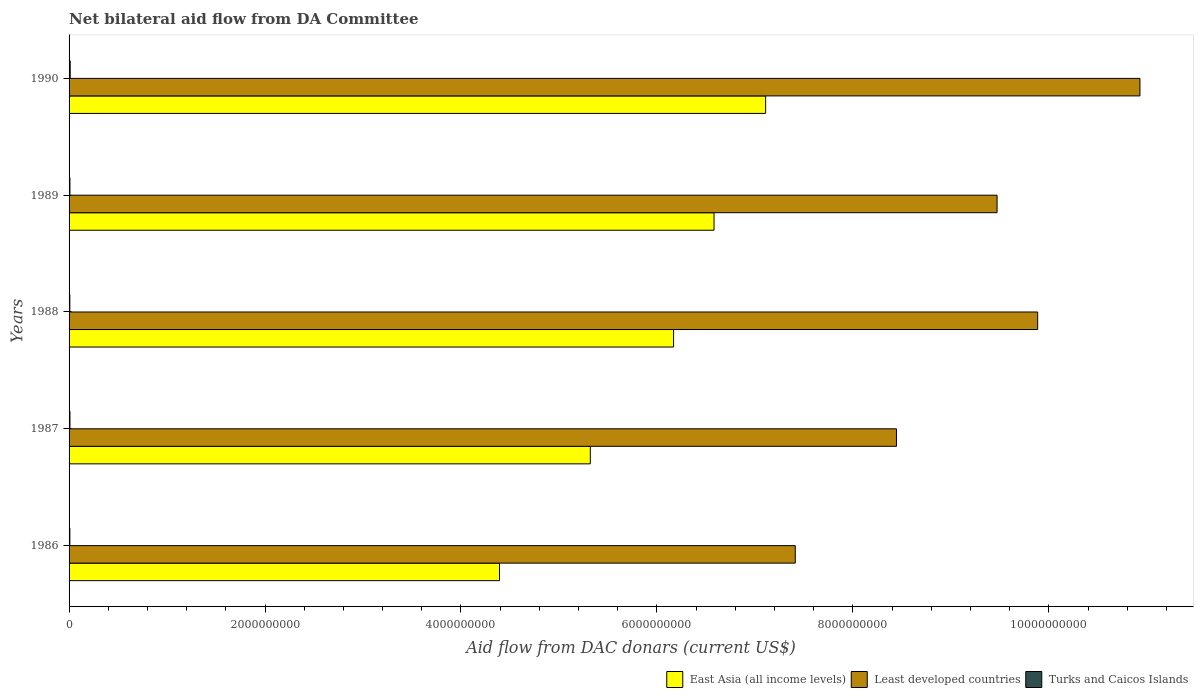How many different coloured bars are there?
Offer a terse response. 3. How many groups of bars are there?
Provide a succinct answer. 5. Are the number of bars per tick equal to the number of legend labels?
Your answer should be very brief. Yes. Are the number of bars on each tick of the Y-axis equal?
Make the answer very short. Yes. What is the aid flow in in Least developed countries in 1990?
Offer a terse response. 1.09e+1. Across all years, what is the maximum aid flow in in Least developed countries?
Offer a terse response. 1.09e+1. Across all years, what is the minimum aid flow in in Turks and Caicos Islands?
Your answer should be very brief. 7.69e+06. In which year was the aid flow in in Turks and Caicos Islands minimum?
Ensure brevity in your answer.  1988. What is the total aid flow in in Least developed countries in the graph?
Ensure brevity in your answer.  4.61e+1. What is the difference between the aid flow in in Turks and Caicos Islands in 1987 and that in 1989?
Your response must be concise. 4.00e+05. What is the difference between the aid flow in in Least developed countries in 1987 and the aid flow in in Turks and Caicos Islands in 1989?
Your response must be concise. 8.44e+09. What is the average aid flow in in East Asia (all income levels) per year?
Offer a terse response. 5.92e+09. In the year 1990, what is the difference between the aid flow in in East Asia (all income levels) and aid flow in in Turks and Caicos Islands?
Your answer should be compact. 7.10e+09. What is the ratio of the aid flow in in Turks and Caicos Islands in 1986 to that in 1989?
Keep it short and to the point. 0.92. Is the aid flow in in Least developed countries in 1987 less than that in 1990?
Your response must be concise. Yes. What is the difference between the highest and the second highest aid flow in in Turks and Caicos Islands?
Offer a terse response. 2.37e+06. What is the difference between the highest and the lowest aid flow in in Turks and Caicos Islands?
Offer a terse response. 3.76e+06. In how many years, is the aid flow in in Least developed countries greater than the average aid flow in in Least developed countries taken over all years?
Offer a terse response. 3. Is the sum of the aid flow in in Turks and Caicos Islands in 1988 and 1990 greater than the maximum aid flow in in East Asia (all income levels) across all years?
Give a very brief answer. No. What does the 2nd bar from the top in 1986 represents?
Give a very brief answer. Least developed countries. What does the 1st bar from the bottom in 1990 represents?
Provide a short and direct response. East Asia (all income levels). Is it the case that in every year, the sum of the aid flow in in Turks and Caicos Islands and aid flow in in East Asia (all income levels) is greater than the aid flow in in Least developed countries?
Keep it short and to the point. No. Are all the bars in the graph horizontal?
Offer a terse response. Yes. What is the difference between two consecutive major ticks on the X-axis?
Provide a short and direct response. 2.00e+09. Does the graph contain grids?
Provide a succinct answer. No. How many legend labels are there?
Give a very brief answer. 3. What is the title of the graph?
Make the answer very short. Net bilateral aid flow from DA Committee. What is the label or title of the X-axis?
Provide a short and direct response. Aid flow from DAC donars (current US$). What is the label or title of the Y-axis?
Your response must be concise. Years. What is the Aid flow from DAC donars (current US$) of East Asia (all income levels) in 1986?
Make the answer very short. 4.39e+09. What is the Aid flow from DAC donars (current US$) in Least developed countries in 1986?
Offer a terse response. 7.41e+09. What is the Aid flow from DAC donars (current US$) of East Asia (all income levels) in 1987?
Provide a succinct answer. 5.32e+09. What is the Aid flow from DAC donars (current US$) of Least developed countries in 1987?
Your response must be concise. 8.45e+09. What is the Aid flow from DAC donars (current US$) in Turks and Caicos Islands in 1987?
Your answer should be very brief. 9.08e+06. What is the Aid flow from DAC donars (current US$) of East Asia (all income levels) in 1988?
Keep it short and to the point. 6.17e+09. What is the Aid flow from DAC donars (current US$) in Least developed countries in 1988?
Your answer should be very brief. 9.89e+09. What is the Aid flow from DAC donars (current US$) of Turks and Caicos Islands in 1988?
Keep it short and to the point. 7.69e+06. What is the Aid flow from DAC donars (current US$) in East Asia (all income levels) in 1989?
Your answer should be compact. 6.58e+09. What is the Aid flow from DAC donars (current US$) of Least developed countries in 1989?
Your answer should be compact. 9.47e+09. What is the Aid flow from DAC donars (current US$) in Turks and Caicos Islands in 1989?
Offer a very short reply. 8.68e+06. What is the Aid flow from DAC donars (current US$) in East Asia (all income levels) in 1990?
Your answer should be very brief. 7.11e+09. What is the Aid flow from DAC donars (current US$) in Least developed countries in 1990?
Keep it short and to the point. 1.09e+1. What is the Aid flow from DAC donars (current US$) of Turks and Caicos Islands in 1990?
Keep it short and to the point. 1.14e+07. Across all years, what is the maximum Aid flow from DAC donars (current US$) in East Asia (all income levels)?
Offer a terse response. 7.11e+09. Across all years, what is the maximum Aid flow from DAC donars (current US$) in Least developed countries?
Provide a short and direct response. 1.09e+1. Across all years, what is the maximum Aid flow from DAC donars (current US$) in Turks and Caicos Islands?
Offer a terse response. 1.14e+07. Across all years, what is the minimum Aid flow from DAC donars (current US$) of East Asia (all income levels)?
Ensure brevity in your answer.  4.39e+09. Across all years, what is the minimum Aid flow from DAC donars (current US$) of Least developed countries?
Your answer should be compact. 7.41e+09. Across all years, what is the minimum Aid flow from DAC donars (current US$) of Turks and Caicos Islands?
Your response must be concise. 7.69e+06. What is the total Aid flow from DAC donars (current US$) of East Asia (all income levels) in the graph?
Your answer should be very brief. 2.96e+1. What is the total Aid flow from DAC donars (current US$) in Least developed countries in the graph?
Your answer should be very brief. 4.61e+1. What is the total Aid flow from DAC donars (current US$) of Turks and Caicos Islands in the graph?
Make the answer very short. 4.49e+07. What is the difference between the Aid flow from DAC donars (current US$) in East Asia (all income levels) in 1986 and that in 1987?
Provide a short and direct response. -9.27e+08. What is the difference between the Aid flow from DAC donars (current US$) of Least developed countries in 1986 and that in 1987?
Provide a short and direct response. -1.03e+09. What is the difference between the Aid flow from DAC donars (current US$) in Turks and Caicos Islands in 1986 and that in 1987?
Provide a short and direct response. -1.08e+06. What is the difference between the Aid flow from DAC donars (current US$) of East Asia (all income levels) in 1986 and that in 1988?
Give a very brief answer. -1.78e+09. What is the difference between the Aid flow from DAC donars (current US$) in Least developed countries in 1986 and that in 1988?
Provide a short and direct response. -2.47e+09. What is the difference between the Aid flow from DAC donars (current US$) in East Asia (all income levels) in 1986 and that in 1989?
Your answer should be compact. -2.19e+09. What is the difference between the Aid flow from DAC donars (current US$) of Least developed countries in 1986 and that in 1989?
Keep it short and to the point. -2.06e+09. What is the difference between the Aid flow from DAC donars (current US$) in Turks and Caicos Islands in 1986 and that in 1989?
Offer a very short reply. -6.80e+05. What is the difference between the Aid flow from DAC donars (current US$) of East Asia (all income levels) in 1986 and that in 1990?
Offer a very short reply. -2.72e+09. What is the difference between the Aid flow from DAC donars (current US$) in Least developed countries in 1986 and that in 1990?
Your response must be concise. -3.52e+09. What is the difference between the Aid flow from DAC donars (current US$) of Turks and Caicos Islands in 1986 and that in 1990?
Provide a succinct answer. -3.45e+06. What is the difference between the Aid flow from DAC donars (current US$) of East Asia (all income levels) in 1987 and that in 1988?
Keep it short and to the point. -8.50e+08. What is the difference between the Aid flow from DAC donars (current US$) of Least developed countries in 1987 and that in 1988?
Make the answer very short. -1.44e+09. What is the difference between the Aid flow from DAC donars (current US$) of Turks and Caicos Islands in 1987 and that in 1988?
Offer a terse response. 1.39e+06. What is the difference between the Aid flow from DAC donars (current US$) in East Asia (all income levels) in 1987 and that in 1989?
Provide a succinct answer. -1.26e+09. What is the difference between the Aid flow from DAC donars (current US$) of Least developed countries in 1987 and that in 1989?
Give a very brief answer. -1.03e+09. What is the difference between the Aid flow from DAC donars (current US$) in East Asia (all income levels) in 1987 and that in 1990?
Provide a succinct answer. -1.79e+09. What is the difference between the Aid flow from DAC donars (current US$) in Least developed countries in 1987 and that in 1990?
Your answer should be compact. -2.49e+09. What is the difference between the Aid flow from DAC donars (current US$) of Turks and Caicos Islands in 1987 and that in 1990?
Offer a terse response. -2.37e+06. What is the difference between the Aid flow from DAC donars (current US$) in East Asia (all income levels) in 1988 and that in 1989?
Offer a very short reply. -4.13e+08. What is the difference between the Aid flow from DAC donars (current US$) in Least developed countries in 1988 and that in 1989?
Provide a succinct answer. 4.14e+08. What is the difference between the Aid flow from DAC donars (current US$) of Turks and Caicos Islands in 1988 and that in 1989?
Your answer should be very brief. -9.90e+05. What is the difference between the Aid flow from DAC donars (current US$) of East Asia (all income levels) in 1988 and that in 1990?
Keep it short and to the point. -9.40e+08. What is the difference between the Aid flow from DAC donars (current US$) of Least developed countries in 1988 and that in 1990?
Your answer should be compact. -1.04e+09. What is the difference between the Aid flow from DAC donars (current US$) in Turks and Caicos Islands in 1988 and that in 1990?
Provide a succinct answer. -3.76e+06. What is the difference between the Aid flow from DAC donars (current US$) in East Asia (all income levels) in 1989 and that in 1990?
Ensure brevity in your answer.  -5.27e+08. What is the difference between the Aid flow from DAC donars (current US$) in Least developed countries in 1989 and that in 1990?
Make the answer very short. -1.46e+09. What is the difference between the Aid flow from DAC donars (current US$) of Turks and Caicos Islands in 1989 and that in 1990?
Provide a succinct answer. -2.77e+06. What is the difference between the Aid flow from DAC donars (current US$) of East Asia (all income levels) in 1986 and the Aid flow from DAC donars (current US$) of Least developed countries in 1987?
Your response must be concise. -4.05e+09. What is the difference between the Aid flow from DAC donars (current US$) in East Asia (all income levels) in 1986 and the Aid flow from DAC donars (current US$) in Turks and Caicos Islands in 1987?
Give a very brief answer. 4.38e+09. What is the difference between the Aid flow from DAC donars (current US$) in Least developed countries in 1986 and the Aid flow from DAC donars (current US$) in Turks and Caicos Islands in 1987?
Provide a succinct answer. 7.40e+09. What is the difference between the Aid flow from DAC donars (current US$) of East Asia (all income levels) in 1986 and the Aid flow from DAC donars (current US$) of Least developed countries in 1988?
Provide a succinct answer. -5.49e+09. What is the difference between the Aid flow from DAC donars (current US$) in East Asia (all income levels) in 1986 and the Aid flow from DAC donars (current US$) in Turks and Caicos Islands in 1988?
Keep it short and to the point. 4.39e+09. What is the difference between the Aid flow from DAC donars (current US$) in Least developed countries in 1986 and the Aid flow from DAC donars (current US$) in Turks and Caicos Islands in 1988?
Keep it short and to the point. 7.40e+09. What is the difference between the Aid flow from DAC donars (current US$) in East Asia (all income levels) in 1986 and the Aid flow from DAC donars (current US$) in Least developed countries in 1989?
Ensure brevity in your answer.  -5.08e+09. What is the difference between the Aid flow from DAC donars (current US$) of East Asia (all income levels) in 1986 and the Aid flow from DAC donars (current US$) of Turks and Caicos Islands in 1989?
Offer a terse response. 4.38e+09. What is the difference between the Aid flow from DAC donars (current US$) of Least developed countries in 1986 and the Aid flow from DAC donars (current US$) of Turks and Caicos Islands in 1989?
Ensure brevity in your answer.  7.40e+09. What is the difference between the Aid flow from DAC donars (current US$) in East Asia (all income levels) in 1986 and the Aid flow from DAC donars (current US$) in Least developed countries in 1990?
Give a very brief answer. -6.54e+09. What is the difference between the Aid flow from DAC donars (current US$) in East Asia (all income levels) in 1986 and the Aid flow from DAC donars (current US$) in Turks and Caicos Islands in 1990?
Provide a succinct answer. 4.38e+09. What is the difference between the Aid flow from DAC donars (current US$) of Least developed countries in 1986 and the Aid flow from DAC donars (current US$) of Turks and Caicos Islands in 1990?
Provide a succinct answer. 7.40e+09. What is the difference between the Aid flow from DAC donars (current US$) in East Asia (all income levels) in 1987 and the Aid flow from DAC donars (current US$) in Least developed countries in 1988?
Provide a short and direct response. -4.57e+09. What is the difference between the Aid flow from DAC donars (current US$) of East Asia (all income levels) in 1987 and the Aid flow from DAC donars (current US$) of Turks and Caicos Islands in 1988?
Offer a very short reply. 5.31e+09. What is the difference between the Aid flow from DAC donars (current US$) of Least developed countries in 1987 and the Aid flow from DAC donars (current US$) of Turks and Caicos Islands in 1988?
Your answer should be compact. 8.44e+09. What is the difference between the Aid flow from DAC donars (current US$) in East Asia (all income levels) in 1987 and the Aid flow from DAC donars (current US$) in Least developed countries in 1989?
Ensure brevity in your answer.  -4.15e+09. What is the difference between the Aid flow from DAC donars (current US$) of East Asia (all income levels) in 1987 and the Aid flow from DAC donars (current US$) of Turks and Caicos Islands in 1989?
Offer a very short reply. 5.31e+09. What is the difference between the Aid flow from DAC donars (current US$) of Least developed countries in 1987 and the Aid flow from DAC donars (current US$) of Turks and Caicos Islands in 1989?
Ensure brevity in your answer.  8.44e+09. What is the difference between the Aid flow from DAC donars (current US$) in East Asia (all income levels) in 1987 and the Aid flow from DAC donars (current US$) in Least developed countries in 1990?
Keep it short and to the point. -5.61e+09. What is the difference between the Aid flow from DAC donars (current US$) of East Asia (all income levels) in 1987 and the Aid flow from DAC donars (current US$) of Turks and Caicos Islands in 1990?
Offer a terse response. 5.31e+09. What is the difference between the Aid flow from DAC donars (current US$) in Least developed countries in 1987 and the Aid flow from DAC donars (current US$) in Turks and Caicos Islands in 1990?
Keep it short and to the point. 8.43e+09. What is the difference between the Aid flow from DAC donars (current US$) of East Asia (all income levels) in 1988 and the Aid flow from DAC donars (current US$) of Least developed countries in 1989?
Keep it short and to the point. -3.30e+09. What is the difference between the Aid flow from DAC donars (current US$) in East Asia (all income levels) in 1988 and the Aid flow from DAC donars (current US$) in Turks and Caicos Islands in 1989?
Ensure brevity in your answer.  6.16e+09. What is the difference between the Aid flow from DAC donars (current US$) of Least developed countries in 1988 and the Aid flow from DAC donars (current US$) of Turks and Caicos Islands in 1989?
Provide a short and direct response. 9.88e+09. What is the difference between the Aid flow from DAC donars (current US$) in East Asia (all income levels) in 1988 and the Aid flow from DAC donars (current US$) in Least developed countries in 1990?
Offer a very short reply. -4.76e+09. What is the difference between the Aid flow from DAC donars (current US$) of East Asia (all income levels) in 1988 and the Aid flow from DAC donars (current US$) of Turks and Caicos Islands in 1990?
Keep it short and to the point. 6.16e+09. What is the difference between the Aid flow from DAC donars (current US$) of Least developed countries in 1988 and the Aid flow from DAC donars (current US$) of Turks and Caicos Islands in 1990?
Offer a terse response. 9.87e+09. What is the difference between the Aid flow from DAC donars (current US$) of East Asia (all income levels) in 1989 and the Aid flow from DAC donars (current US$) of Least developed countries in 1990?
Make the answer very short. -4.35e+09. What is the difference between the Aid flow from DAC donars (current US$) in East Asia (all income levels) in 1989 and the Aid flow from DAC donars (current US$) in Turks and Caicos Islands in 1990?
Provide a short and direct response. 6.57e+09. What is the difference between the Aid flow from DAC donars (current US$) of Least developed countries in 1989 and the Aid flow from DAC donars (current US$) of Turks and Caicos Islands in 1990?
Your answer should be compact. 9.46e+09. What is the average Aid flow from DAC donars (current US$) of East Asia (all income levels) per year?
Provide a succinct answer. 5.92e+09. What is the average Aid flow from DAC donars (current US$) of Least developed countries per year?
Offer a very short reply. 9.23e+09. What is the average Aid flow from DAC donars (current US$) of Turks and Caicos Islands per year?
Your response must be concise. 8.98e+06. In the year 1986, what is the difference between the Aid flow from DAC donars (current US$) in East Asia (all income levels) and Aid flow from DAC donars (current US$) in Least developed countries?
Provide a short and direct response. -3.02e+09. In the year 1986, what is the difference between the Aid flow from DAC donars (current US$) in East Asia (all income levels) and Aid flow from DAC donars (current US$) in Turks and Caicos Islands?
Your answer should be compact. 4.39e+09. In the year 1986, what is the difference between the Aid flow from DAC donars (current US$) in Least developed countries and Aid flow from DAC donars (current US$) in Turks and Caicos Islands?
Make the answer very short. 7.40e+09. In the year 1987, what is the difference between the Aid flow from DAC donars (current US$) of East Asia (all income levels) and Aid flow from DAC donars (current US$) of Least developed countries?
Provide a short and direct response. -3.12e+09. In the year 1987, what is the difference between the Aid flow from DAC donars (current US$) of East Asia (all income levels) and Aid flow from DAC donars (current US$) of Turks and Caicos Islands?
Keep it short and to the point. 5.31e+09. In the year 1987, what is the difference between the Aid flow from DAC donars (current US$) in Least developed countries and Aid flow from DAC donars (current US$) in Turks and Caicos Islands?
Ensure brevity in your answer.  8.44e+09. In the year 1988, what is the difference between the Aid flow from DAC donars (current US$) in East Asia (all income levels) and Aid flow from DAC donars (current US$) in Least developed countries?
Offer a very short reply. -3.72e+09. In the year 1988, what is the difference between the Aid flow from DAC donars (current US$) of East Asia (all income levels) and Aid flow from DAC donars (current US$) of Turks and Caicos Islands?
Offer a terse response. 6.16e+09. In the year 1988, what is the difference between the Aid flow from DAC donars (current US$) in Least developed countries and Aid flow from DAC donars (current US$) in Turks and Caicos Islands?
Offer a terse response. 9.88e+09. In the year 1989, what is the difference between the Aid flow from DAC donars (current US$) of East Asia (all income levels) and Aid flow from DAC donars (current US$) of Least developed countries?
Ensure brevity in your answer.  -2.89e+09. In the year 1989, what is the difference between the Aid flow from DAC donars (current US$) in East Asia (all income levels) and Aid flow from DAC donars (current US$) in Turks and Caicos Islands?
Keep it short and to the point. 6.57e+09. In the year 1989, what is the difference between the Aid flow from DAC donars (current US$) of Least developed countries and Aid flow from DAC donars (current US$) of Turks and Caicos Islands?
Offer a very short reply. 9.46e+09. In the year 1990, what is the difference between the Aid flow from DAC donars (current US$) in East Asia (all income levels) and Aid flow from DAC donars (current US$) in Least developed countries?
Your response must be concise. -3.82e+09. In the year 1990, what is the difference between the Aid flow from DAC donars (current US$) in East Asia (all income levels) and Aid flow from DAC donars (current US$) in Turks and Caicos Islands?
Give a very brief answer. 7.10e+09. In the year 1990, what is the difference between the Aid flow from DAC donars (current US$) of Least developed countries and Aid flow from DAC donars (current US$) of Turks and Caicos Islands?
Your answer should be very brief. 1.09e+1. What is the ratio of the Aid flow from DAC donars (current US$) in East Asia (all income levels) in 1986 to that in 1987?
Ensure brevity in your answer.  0.83. What is the ratio of the Aid flow from DAC donars (current US$) of Least developed countries in 1986 to that in 1987?
Provide a short and direct response. 0.88. What is the ratio of the Aid flow from DAC donars (current US$) of Turks and Caicos Islands in 1986 to that in 1987?
Your answer should be very brief. 0.88. What is the ratio of the Aid flow from DAC donars (current US$) of East Asia (all income levels) in 1986 to that in 1988?
Offer a terse response. 0.71. What is the ratio of the Aid flow from DAC donars (current US$) of Least developed countries in 1986 to that in 1988?
Provide a short and direct response. 0.75. What is the ratio of the Aid flow from DAC donars (current US$) of Turks and Caicos Islands in 1986 to that in 1988?
Provide a short and direct response. 1.04. What is the ratio of the Aid flow from DAC donars (current US$) in East Asia (all income levels) in 1986 to that in 1989?
Give a very brief answer. 0.67. What is the ratio of the Aid flow from DAC donars (current US$) in Least developed countries in 1986 to that in 1989?
Give a very brief answer. 0.78. What is the ratio of the Aid flow from DAC donars (current US$) of Turks and Caicos Islands in 1986 to that in 1989?
Ensure brevity in your answer.  0.92. What is the ratio of the Aid flow from DAC donars (current US$) in East Asia (all income levels) in 1986 to that in 1990?
Your response must be concise. 0.62. What is the ratio of the Aid flow from DAC donars (current US$) of Least developed countries in 1986 to that in 1990?
Ensure brevity in your answer.  0.68. What is the ratio of the Aid flow from DAC donars (current US$) in Turks and Caicos Islands in 1986 to that in 1990?
Offer a very short reply. 0.7. What is the ratio of the Aid flow from DAC donars (current US$) in East Asia (all income levels) in 1987 to that in 1988?
Offer a terse response. 0.86. What is the ratio of the Aid flow from DAC donars (current US$) of Least developed countries in 1987 to that in 1988?
Keep it short and to the point. 0.85. What is the ratio of the Aid flow from DAC donars (current US$) of Turks and Caicos Islands in 1987 to that in 1988?
Offer a very short reply. 1.18. What is the ratio of the Aid flow from DAC donars (current US$) of East Asia (all income levels) in 1987 to that in 1989?
Provide a short and direct response. 0.81. What is the ratio of the Aid flow from DAC donars (current US$) of Least developed countries in 1987 to that in 1989?
Your response must be concise. 0.89. What is the ratio of the Aid flow from DAC donars (current US$) of Turks and Caicos Islands in 1987 to that in 1989?
Make the answer very short. 1.05. What is the ratio of the Aid flow from DAC donars (current US$) of East Asia (all income levels) in 1987 to that in 1990?
Keep it short and to the point. 0.75. What is the ratio of the Aid flow from DAC donars (current US$) of Least developed countries in 1987 to that in 1990?
Keep it short and to the point. 0.77. What is the ratio of the Aid flow from DAC donars (current US$) of Turks and Caicos Islands in 1987 to that in 1990?
Ensure brevity in your answer.  0.79. What is the ratio of the Aid flow from DAC donars (current US$) in East Asia (all income levels) in 1988 to that in 1989?
Offer a terse response. 0.94. What is the ratio of the Aid flow from DAC donars (current US$) of Least developed countries in 1988 to that in 1989?
Your response must be concise. 1.04. What is the ratio of the Aid flow from DAC donars (current US$) in Turks and Caicos Islands in 1988 to that in 1989?
Your answer should be compact. 0.89. What is the ratio of the Aid flow from DAC donars (current US$) of East Asia (all income levels) in 1988 to that in 1990?
Your answer should be compact. 0.87. What is the ratio of the Aid flow from DAC donars (current US$) of Least developed countries in 1988 to that in 1990?
Offer a terse response. 0.9. What is the ratio of the Aid flow from DAC donars (current US$) in Turks and Caicos Islands in 1988 to that in 1990?
Give a very brief answer. 0.67. What is the ratio of the Aid flow from DAC donars (current US$) in East Asia (all income levels) in 1989 to that in 1990?
Give a very brief answer. 0.93. What is the ratio of the Aid flow from DAC donars (current US$) in Least developed countries in 1989 to that in 1990?
Give a very brief answer. 0.87. What is the ratio of the Aid flow from DAC donars (current US$) of Turks and Caicos Islands in 1989 to that in 1990?
Your answer should be very brief. 0.76. What is the difference between the highest and the second highest Aid flow from DAC donars (current US$) in East Asia (all income levels)?
Offer a terse response. 5.27e+08. What is the difference between the highest and the second highest Aid flow from DAC donars (current US$) in Least developed countries?
Your answer should be compact. 1.04e+09. What is the difference between the highest and the second highest Aid flow from DAC donars (current US$) of Turks and Caicos Islands?
Offer a terse response. 2.37e+06. What is the difference between the highest and the lowest Aid flow from DAC donars (current US$) of East Asia (all income levels)?
Give a very brief answer. 2.72e+09. What is the difference between the highest and the lowest Aid flow from DAC donars (current US$) of Least developed countries?
Give a very brief answer. 3.52e+09. What is the difference between the highest and the lowest Aid flow from DAC donars (current US$) in Turks and Caicos Islands?
Your response must be concise. 3.76e+06. 